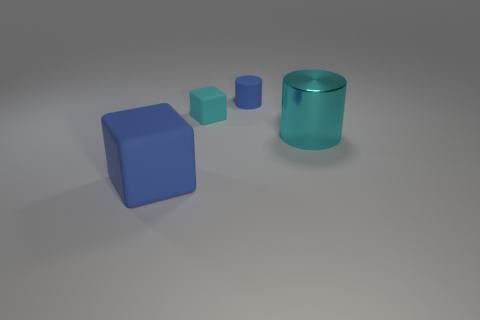Add 2 blue rubber things. How many objects exist? 6 Subtract 0 yellow cylinders. How many objects are left? 4 Subtract all cyan things. Subtract all big cyan metallic objects. How many objects are left? 1 Add 3 big blue matte things. How many big blue matte things are left? 4 Add 3 large cylinders. How many large cylinders exist? 4 